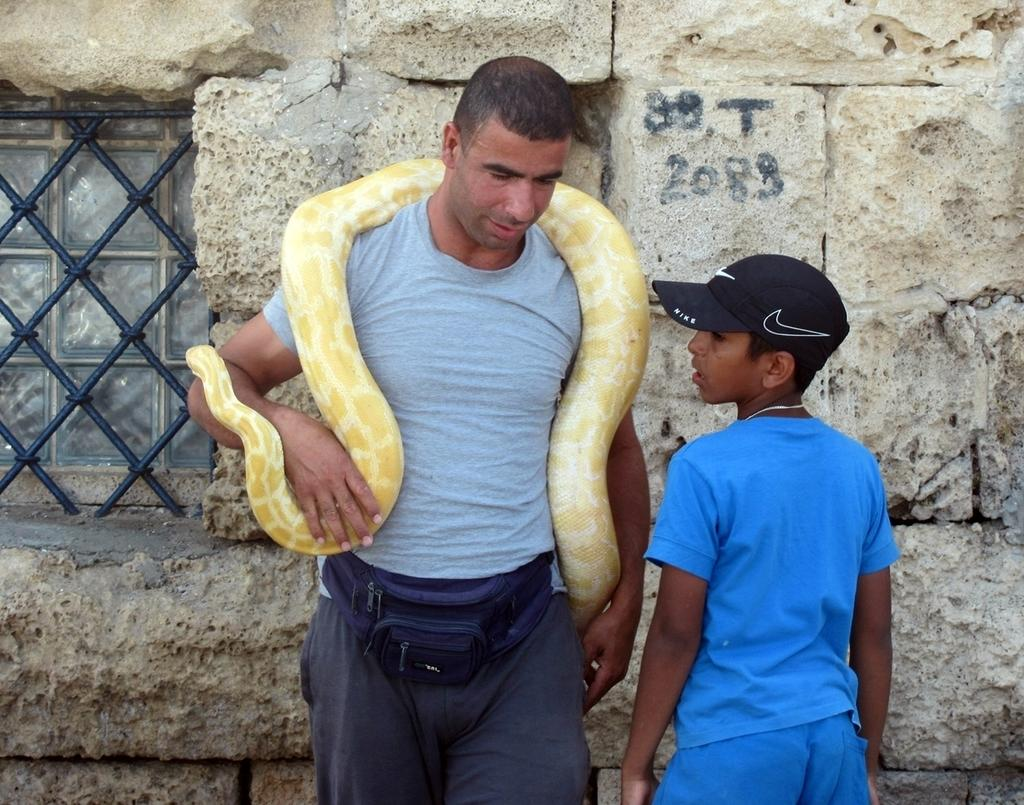Who are the people in the image? There is a man and a boy in the image. What is the man holding around his neck? The man is holding a snake around his neck. What can be seen in the background of the image? There is a wall and rods in the background of the image. How many friends are visible in the image? There is no mention of friends in the image, only a man and a boy. What type of cake is being pointed at in the image? There is no cake or pointing gesture present in the image. 